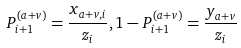Convert formula to latex. <formula><loc_0><loc_0><loc_500><loc_500>P _ { i + 1 } ^ { ( a + v ) } = \frac { x _ { a + v , i } } { z _ { i } } , 1 - P _ { i + 1 } ^ { ( a + v ) } = \frac { y _ { a + v } } { z _ { i } }</formula> 